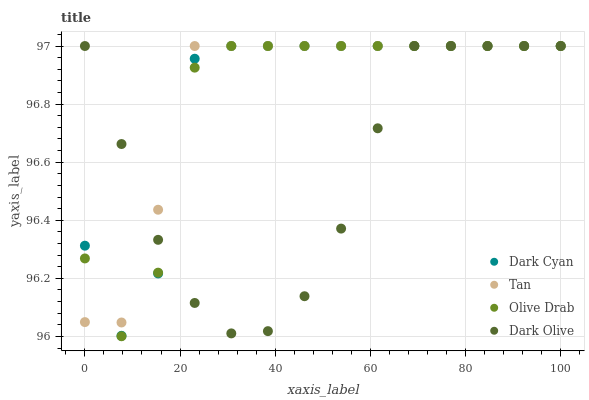Does Dark Olive have the minimum area under the curve?
Answer yes or no. Yes. Does Tan have the maximum area under the curve?
Answer yes or no. Yes. Does Tan have the minimum area under the curve?
Answer yes or no. No. Does Dark Olive have the maximum area under the curve?
Answer yes or no. No. Is Dark Olive the smoothest?
Answer yes or no. Yes. Is Dark Cyan the roughest?
Answer yes or no. Yes. Is Tan the smoothest?
Answer yes or no. No. Is Tan the roughest?
Answer yes or no. No. Does Olive Drab have the lowest value?
Answer yes or no. Yes. Does Dark Olive have the lowest value?
Answer yes or no. No. Does Olive Drab have the highest value?
Answer yes or no. Yes. Does Olive Drab intersect Dark Olive?
Answer yes or no. Yes. Is Olive Drab less than Dark Olive?
Answer yes or no. No. Is Olive Drab greater than Dark Olive?
Answer yes or no. No. 